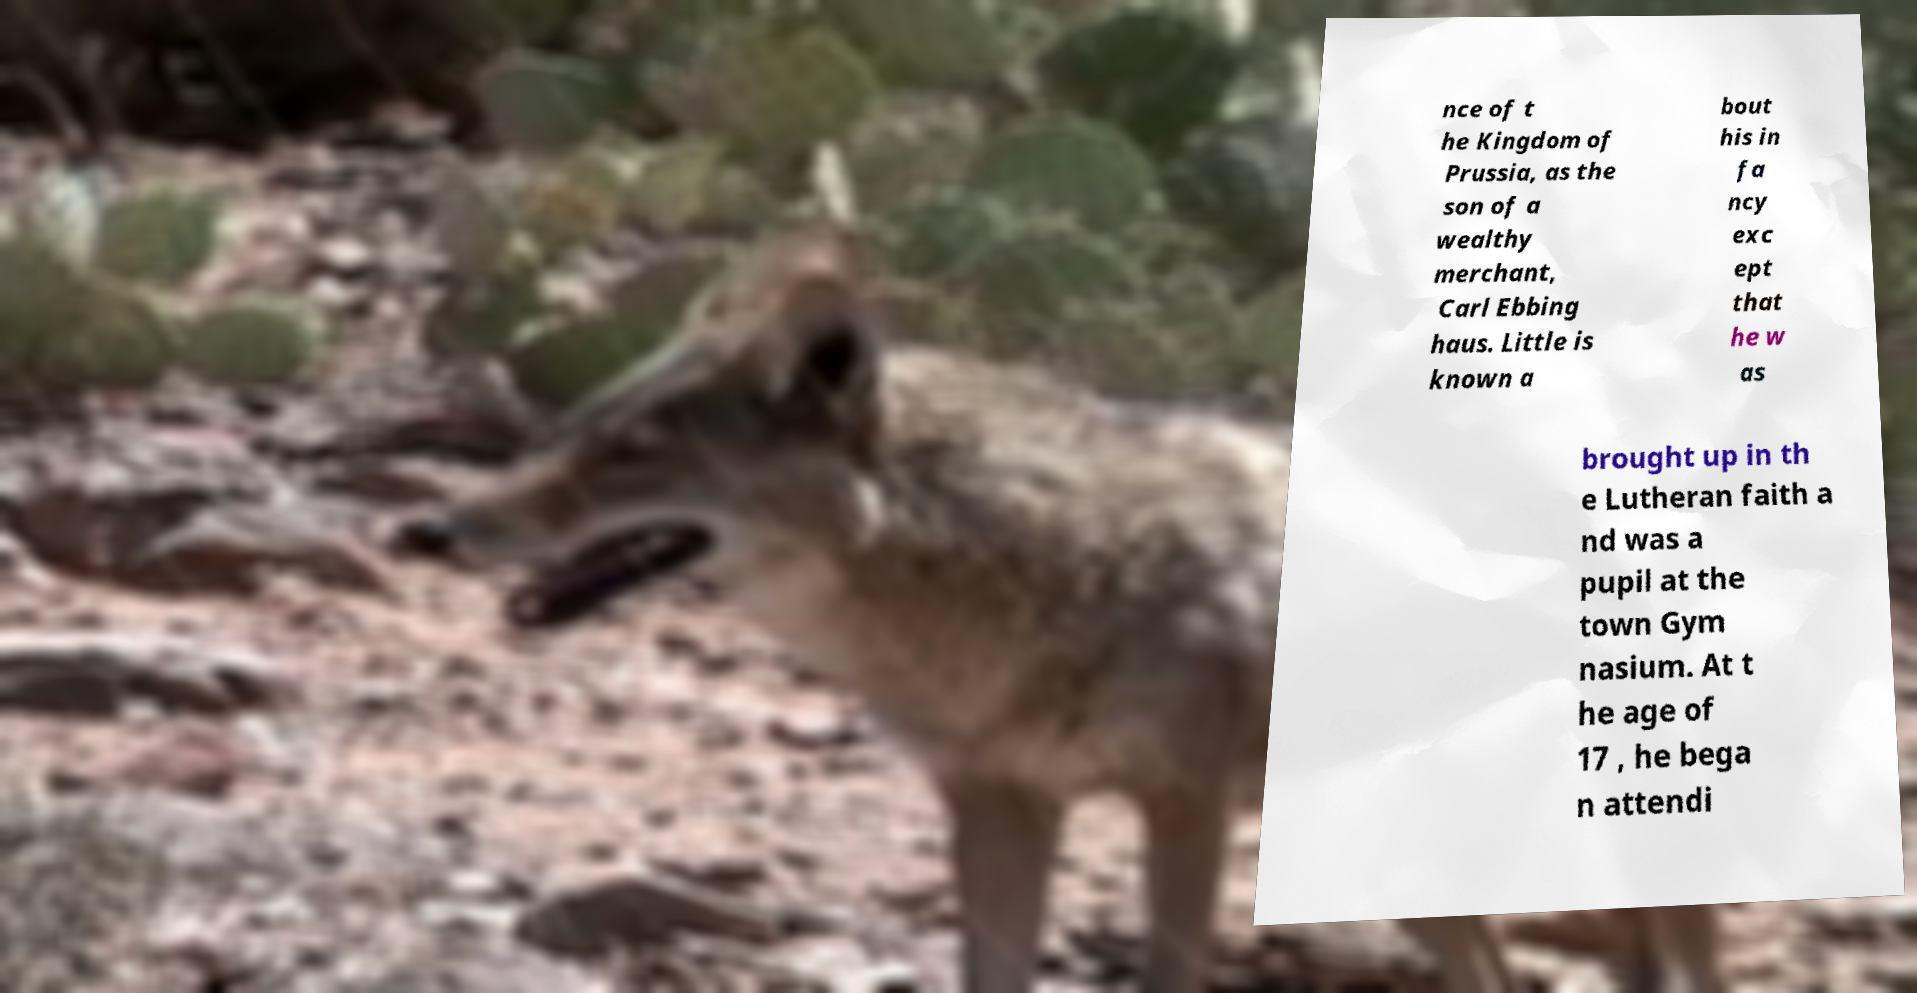Could you assist in decoding the text presented in this image and type it out clearly? nce of t he Kingdom of Prussia, as the son of a wealthy merchant, Carl Ebbing haus. Little is known a bout his in fa ncy exc ept that he w as brought up in th e Lutheran faith a nd was a pupil at the town Gym nasium. At t he age of 17 , he bega n attendi 